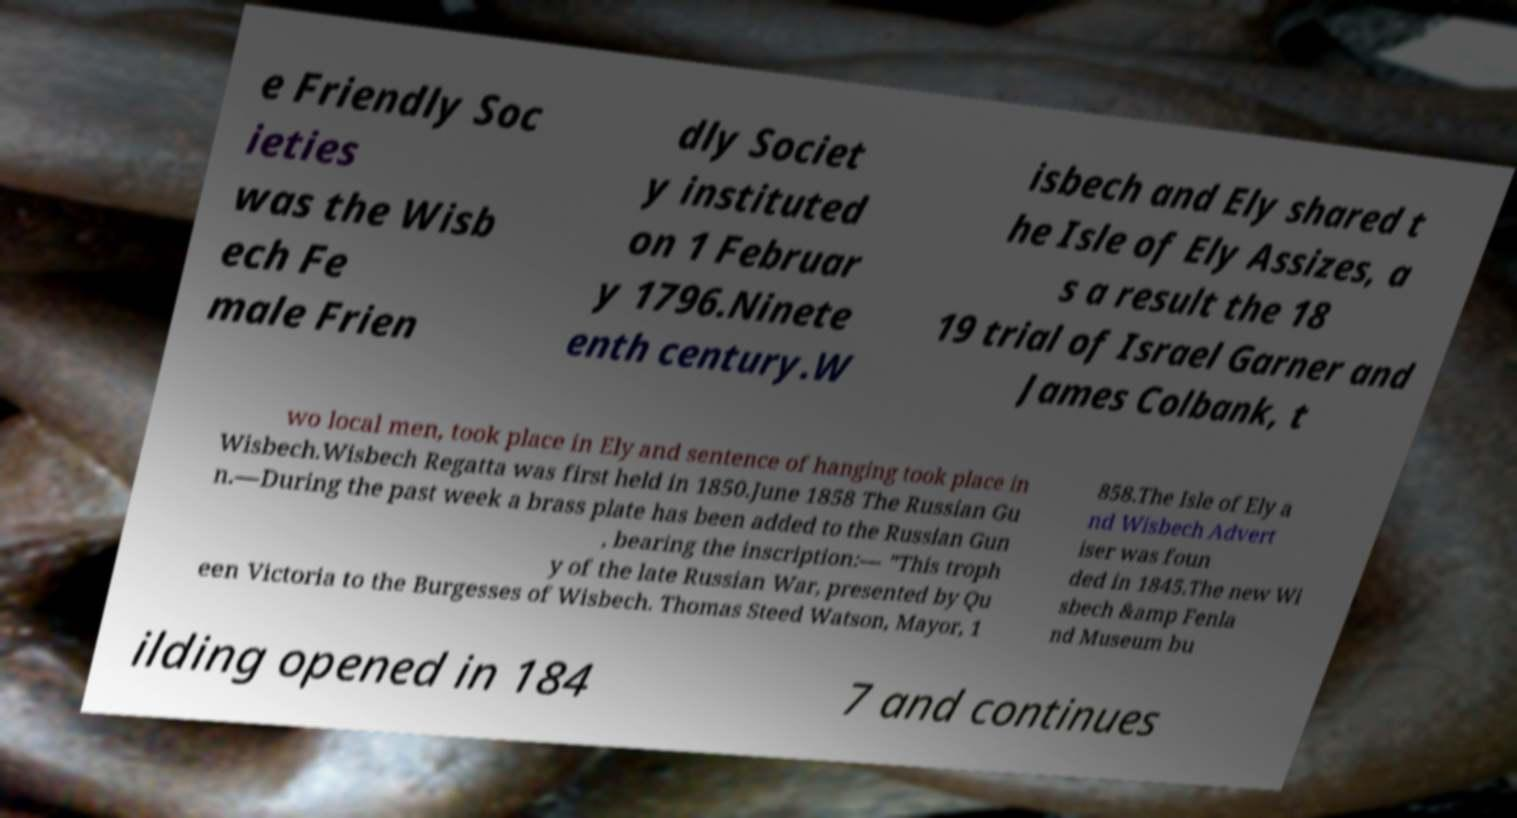For documentation purposes, I need the text within this image transcribed. Could you provide that? e Friendly Soc ieties was the Wisb ech Fe male Frien dly Societ y instituted on 1 Februar y 1796.Ninete enth century.W isbech and Ely shared t he Isle of Ely Assizes, a s a result the 18 19 trial of Israel Garner and James Colbank, t wo local men, took place in Ely and sentence of hanging took place in Wisbech.Wisbech Regatta was first held in 1850.June 1858 The Russian Gu n.—During the past week a brass plate has been added to the Russian Gun , bearing the inscription:— "This troph y of the late Russian War, presented by Qu een Victoria to the Burgesses of Wisbech. Thomas Steed Watson, Mayor, 1 858.The Isle of Ely a nd Wisbech Advert iser was foun ded in 1845.The new Wi sbech &amp Fenla nd Museum bu ilding opened in 184 7 and continues 